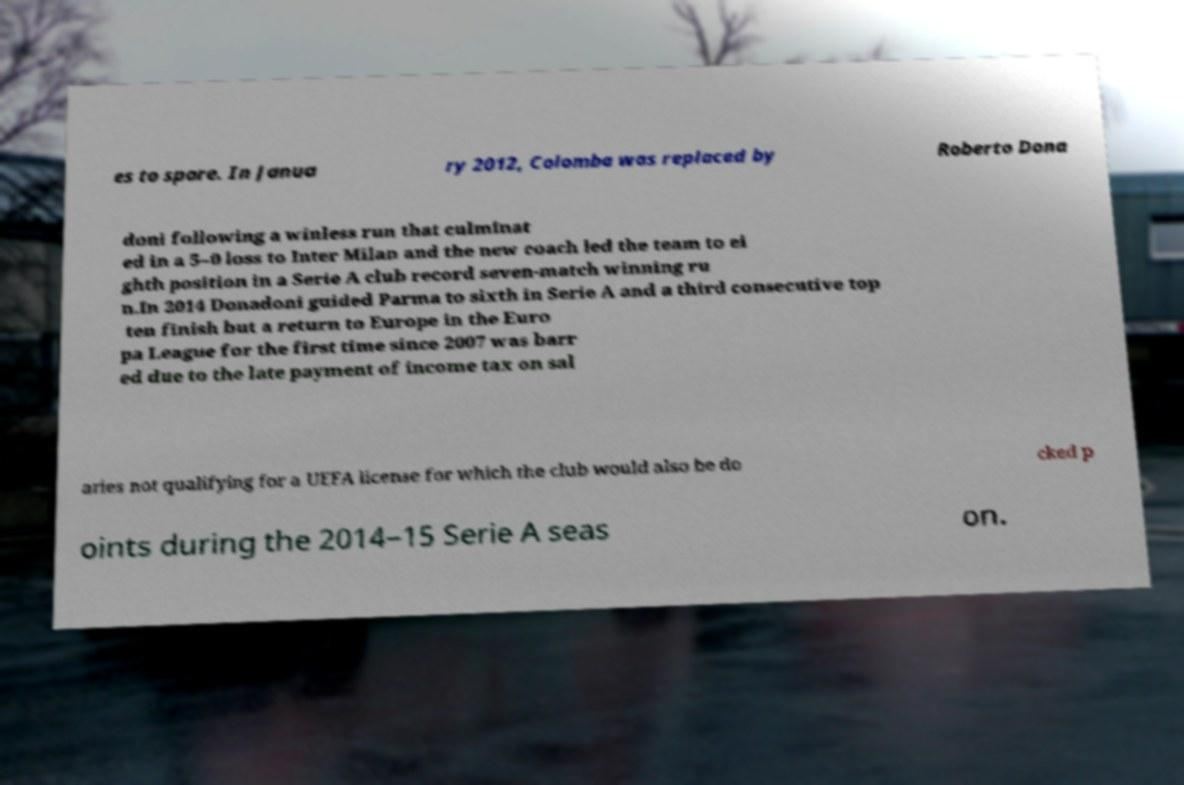Could you extract and type out the text from this image? es to spare. In Janua ry 2012, Colomba was replaced by Roberto Dona doni following a winless run that culminat ed in a 5–0 loss to Inter Milan and the new coach led the team to ei ghth position in a Serie A club record seven-match winning ru n.In 2014 Donadoni guided Parma to sixth in Serie A and a third consecutive top ten finish but a return to Europe in the Euro pa League for the first time since 2007 was barr ed due to the late payment of income tax on sal aries not qualifying for a UEFA license for which the club would also be do cked p oints during the 2014–15 Serie A seas on. 